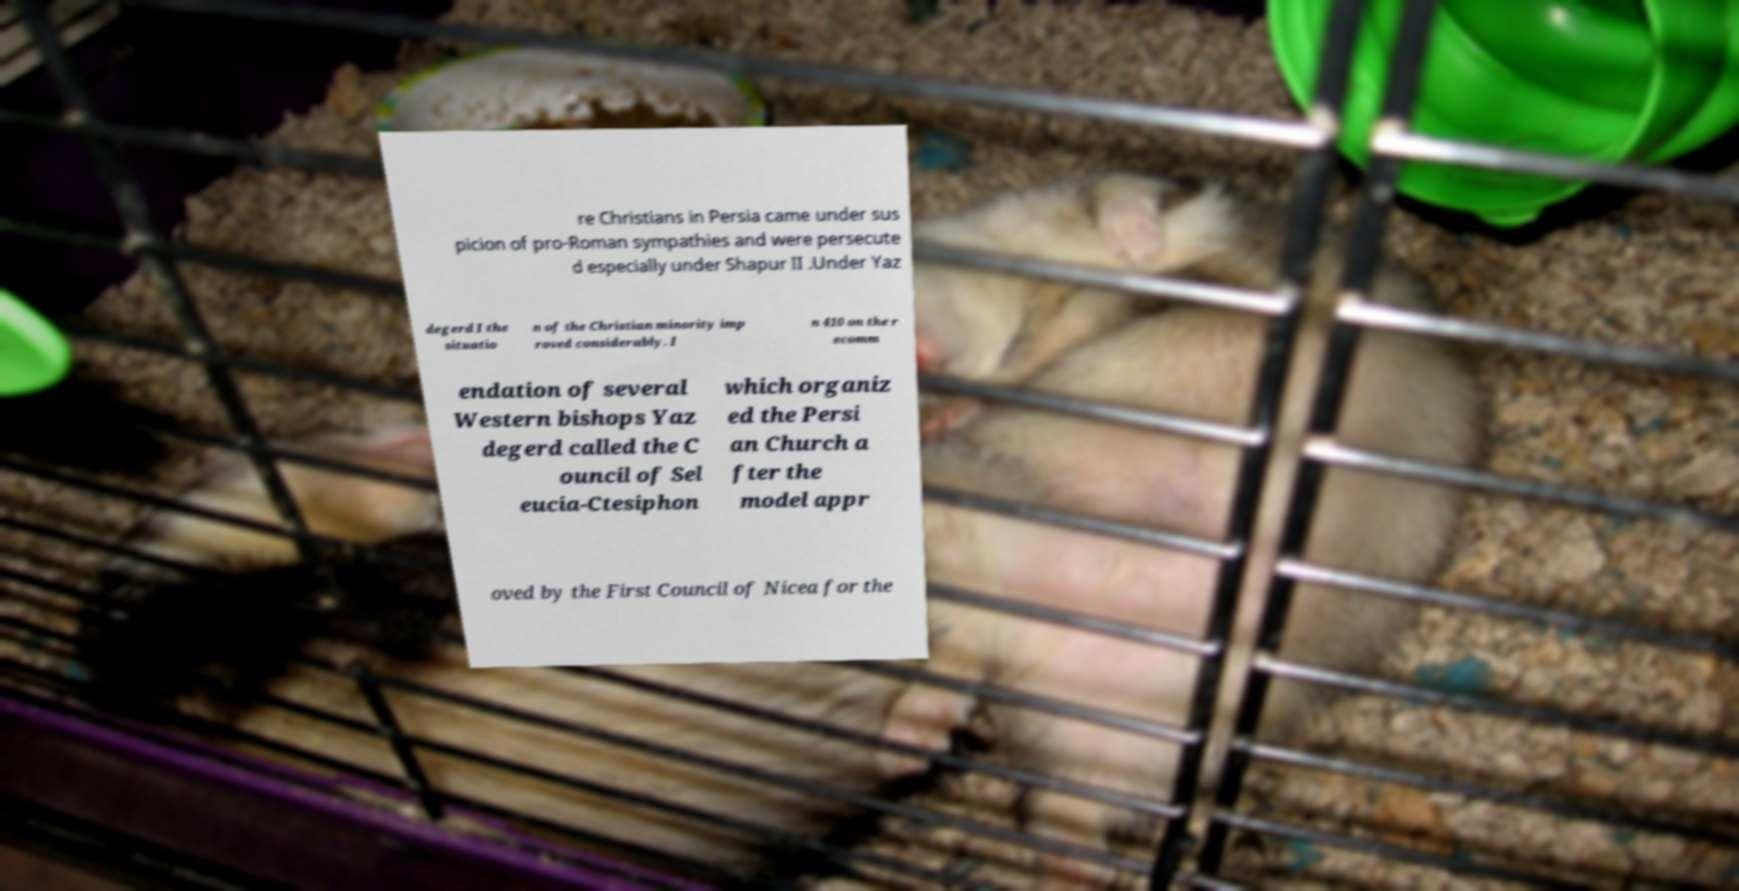Can you accurately transcribe the text from the provided image for me? re Christians in Persia came under sus picion of pro-Roman sympathies and were persecute d especially under Shapur II .Under Yaz degerd I the situatio n of the Christian minority imp roved considerably. I n 410 on the r ecomm endation of several Western bishops Yaz degerd called the C ouncil of Sel eucia-Ctesiphon which organiz ed the Persi an Church a fter the model appr oved by the First Council of Nicea for the 